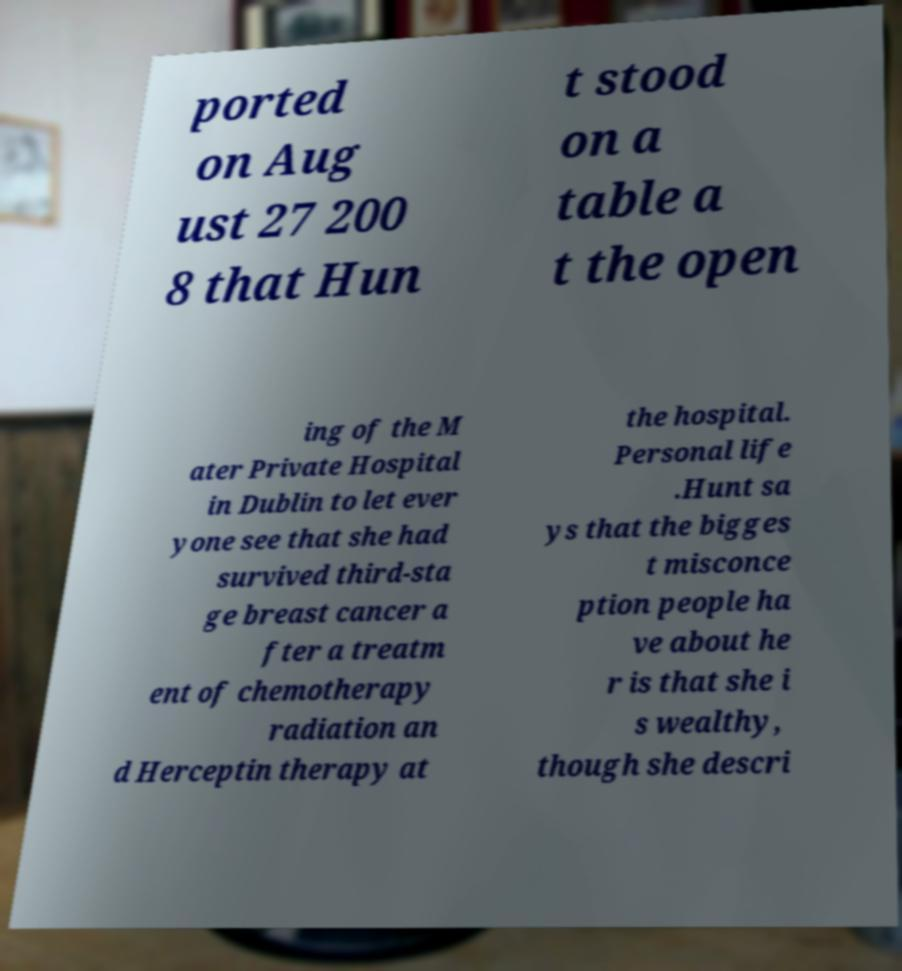I need the written content from this picture converted into text. Can you do that? ported on Aug ust 27 200 8 that Hun t stood on a table a t the open ing of the M ater Private Hospital in Dublin to let ever yone see that she had survived third-sta ge breast cancer a fter a treatm ent of chemotherapy radiation an d Herceptin therapy at the hospital. Personal life .Hunt sa ys that the bigges t misconce ption people ha ve about he r is that she i s wealthy, though she descri 